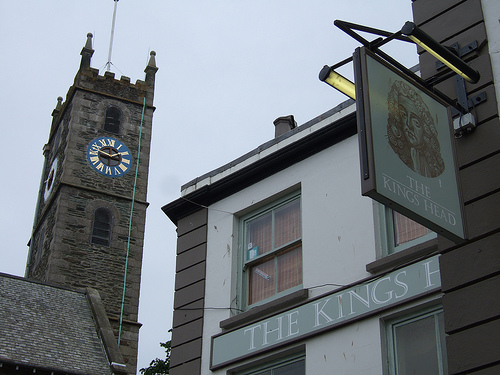Does the blue clock look round and small? No, the blue clock is not round and small; instead, it features a distinctive square shape with a bold, blue frame making it a focal point of the image. 